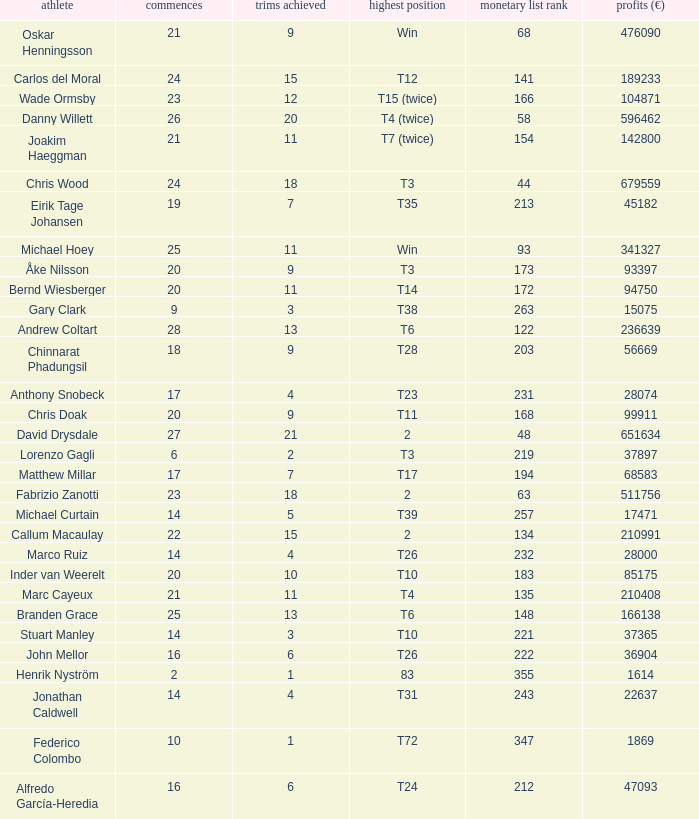Write the full table. {'header': ['athlete', 'commences', 'trims achieved', 'highest position', 'monetary list rank', 'profits (€)'], 'rows': [['Oskar Henningsson', '21', '9', 'Win', '68', '476090'], ['Carlos del Moral', '24', '15', 'T12', '141', '189233'], ['Wade Ormsby', '23', '12', 'T15 (twice)', '166', '104871'], ['Danny Willett', '26', '20', 'T4 (twice)', '58', '596462'], ['Joakim Haeggman', '21', '11', 'T7 (twice)', '154', '142800'], ['Chris Wood', '24', '18', 'T3', '44', '679559'], ['Eirik Tage Johansen', '19', '7', 'T35', '213', '45182'], ['Michael Hoey', '25', '11', 'Win', '93', '341327'], ['Åke Nilsson', '20', '9', 'T3', '173', '93397'], ['Bernd Wiesberger', '20', '11', 'T14', '172', '94750'], ['Gary Clark', '9', '3', 'T38', '263', '15075'], ['Andrew Coltart', '28', '13', 'T6', '122', '236639'], ['Chinnarat Phadungsil', '18', '9', 'T28', '203', '56669'], ['Anthony Snobeck', '17', '4', 'T23', '231', '28074'], ['Chris Doak', '20', '9', 'T11', '168', '99911'], ['David Drysdale', '27', '21', '2', '48', '651634'], ['Lorenzo Gagli', '6', '2', 'T3', '219', '37897'], ['Matthew Millar', '17', '7', 'T17', '194', '68583'], ['Fabrizio Zanotti', '23', '18', '2', '63', '511756'], ['Michael Curtain', '14', '5', 'T39', '257', '17471'], ['Callum Macaulay', '22', '15', '2', '134', '210991'], ['Marco Ruiz', '14', '4', 'T26', '232', '28000'], ['Inder van Weerelt', '20', '10', 'T10', '183', '85175'], ['Marc Cayeux', '21', '11', 'T4', '135', '210408'], ['Branden Grace', '25', '13', 'T6', '148', '166138'], ['Stuart Manley', '14', '3', 'T10', '221', '37365'], ['John Mellor', '16', '6', 'T26', '222', '36904'], ['Henrik Nyström', '2', '1', '83', '355', '1614'], ['Jonathan Caldwell', '14', '4', 'T31', '243', '22637'], ['Federico Colombo', '10', '1', 'T72', '347', '1869'], ['Alfredo García-Heredia', '16', '6', 'T24', '212', '47093']]} How many earnings values are associated with players who had a best finish of T38? 1.0. 